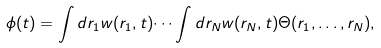<formula> <loc_0><loc_0><loc_500><loc_500>\phi ( t ) = \int d r _ { 1 } w ( r _ { 1 } , t ) \dots \int d r _ { N } w ( r _ { N } , t ) \Theta ( r _ { 1 } , \dots , r _ { N } ) ,</formula> 